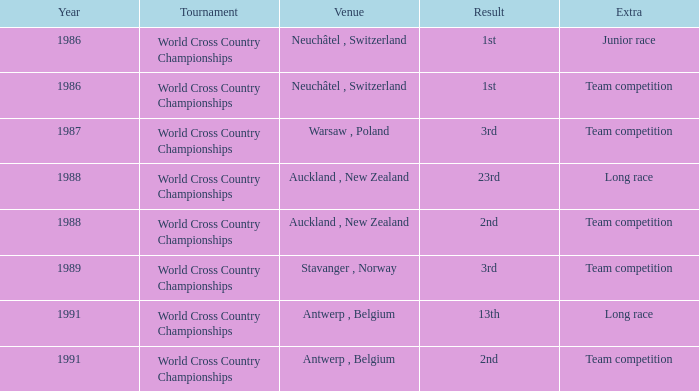Which venue led to a result of 23rd? Auckland , New Zealand. 